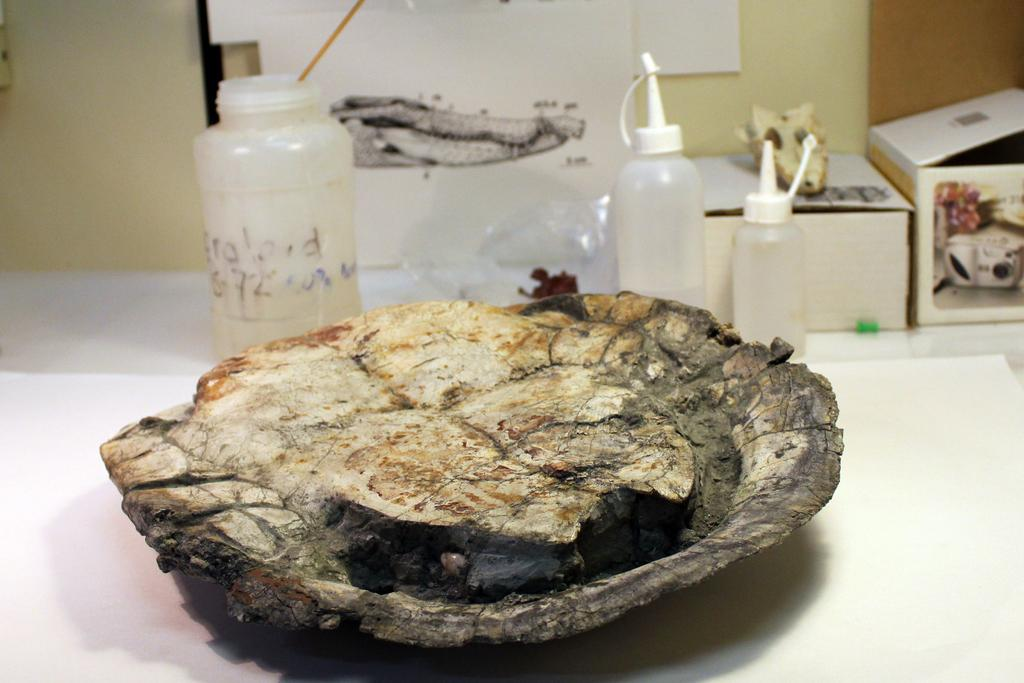What animal is the main subject of the image? There is a tortoise in the image. Where is the tortoise located? The tortoise is placed on a table. What can be seen in the background of the image? There are bottles, a drawing, and a wall in the background of the image. Can you tell me how many rays are swimming in the image? There are no rays present in the image; it features a tortoise on a table. Is the tortoise biting anything in the image? There is no indication in the image that the tortoise is biting anything. 